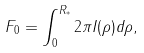<formula> <loc_0><loc_0><loc_500><loc_500>F _ { 0 } = \int _ { 0 } ^ { R _ { * } } 2 \pi I ( \rho ) d \rho ,</formula> 